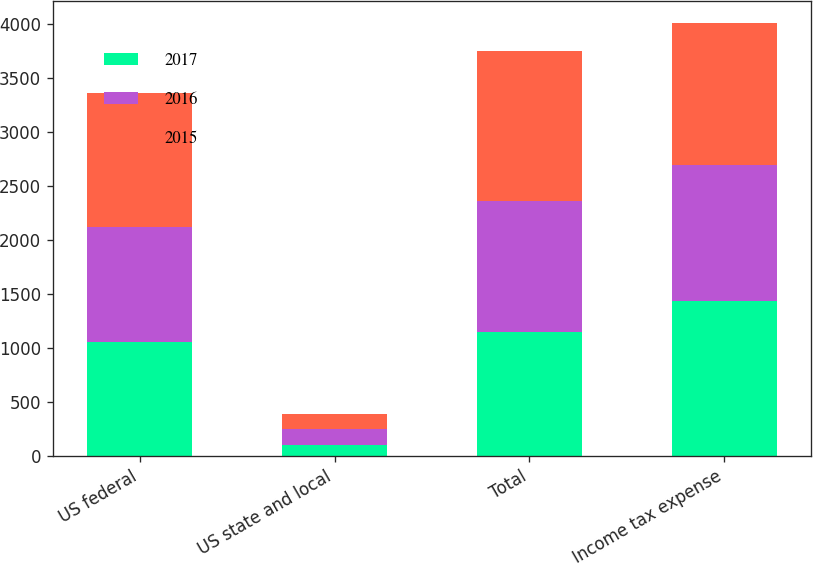<chart> <loc_0><loc_0><loc_500><loc_500><stacked_bar_chart><ecel><fcel>US federal<fcel>US state and local<fcel>Total<fcel>Income tax expense<nl><fcel>2017<fcel>1056<fcel>96<fcel>1152<fcel>1438<nl><fcel>2016<fcel>1066<fcel>149<fcel>1215<fcel>1263<nl><fcel>2015<fcel>1245<fcel>143<fcel>1388<fcel>1315<nl></chart> 